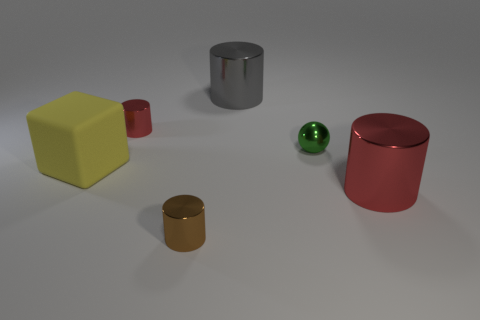Do the small brown object and the yellow rubber thing have the same shape?
Offer a very short reply. No. What is the color of the tiny metallic object that is in front of the red thing that is in front of the block?
Offer a very short reply. Brown. There is a cylinder that is behind the cube and right of the tiny red metallic object; what size is it?
Provide a short and direct response. Large. Is there anything else that is the same color as the small sphere?
Make the answer very short. No. What shape is the brown thing that is made of the same material as the gray cylinder?
Your answer should be compact. Cylinder. Does the tiny red thing have the same shape as the brown metallic thing right of the yellow block?
Your answer should be very brief. Yes. What is the red cylinder in front of the small shiny object left of the tiny brown cylinder made of?
Your response must be concise. Metal. Are there an equal number of red shiny cylinders to the left of the small brown shiny cylinder and red metal things?
Ensure brevity in your answer.  No. Is there anything else that is made of the same material as the brown object?
Your answer should be compact. Yes. Do the large rubber thing that is behind the small brown metallic cylinder and the tiny shiny thing that is in front of the big matte block have the same color?
Give a very brief answer. No. 